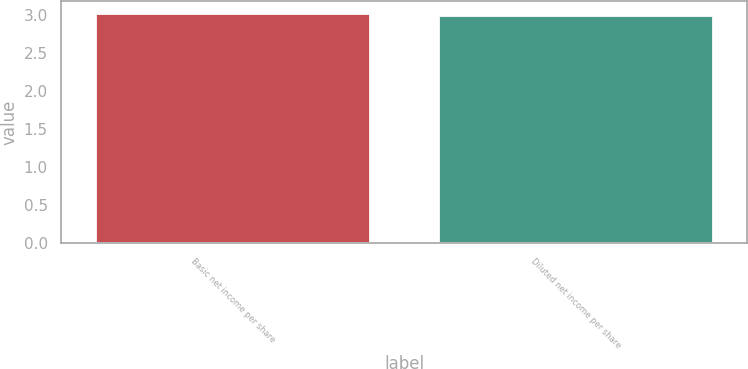Convert chart to OTSL. <chart><loc_0><loc_0><loc_500><loc_500><bar_chart><fcel>Basic net income per share<fcel>Diluted net income per share<nl><fcel>3.03<fcel>3<nl></chart> 